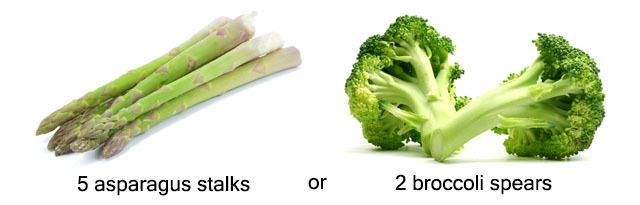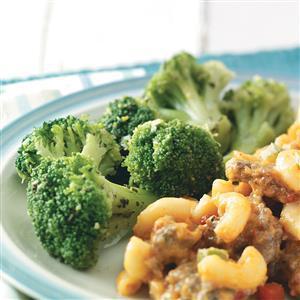The first image is the image on the left, the second image is the image on the right. Assess this claim about the two images: "An image shows a round dish that contains only broccoli.". Correct or not? Answer yes or no. No. The first image is the image on the left, the second image is the image on the right. For the images displayed, is the sentence "There are two veggies shown in the image on the left." factually correct? Answer yes or no. Yes. 